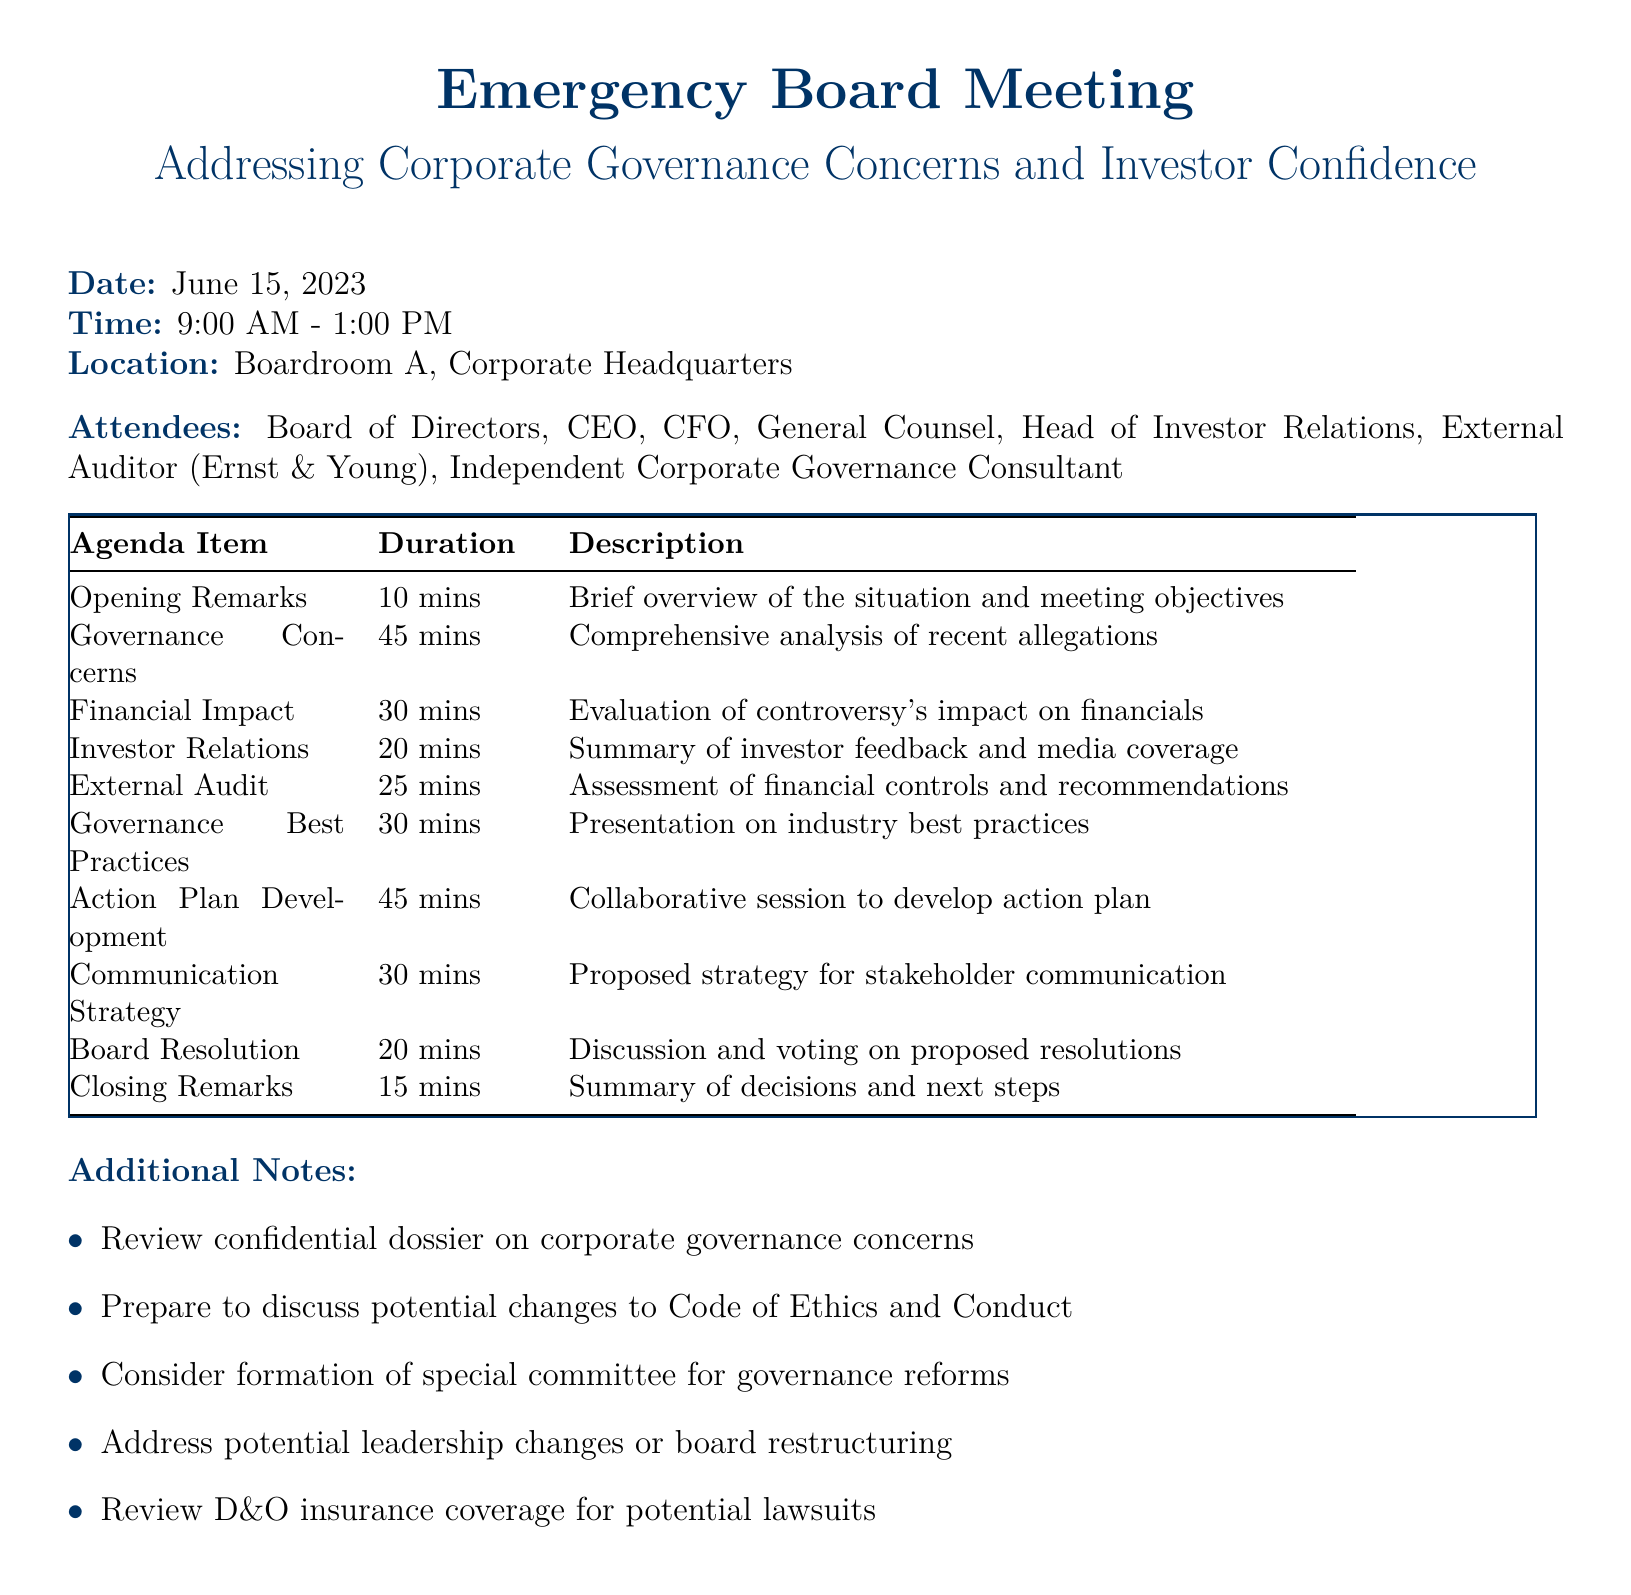What is the date of the meeting? The date of the meeting is mentioned in the document, which is specifically stated at the beginning.
Answer: June 15, 2023 Who is presenting the Financial Impact Assessment? The document lists presenters for each agenda item, thus indicating who is responsible for the Financial Impact Assessment.
Answer: CFO How long is the Opening Remarks segment? The duration of each agenda item is provided in the document next to the respective titles, indicating how long Opening Remarks will last.
Answer: 10 minutes What is being discussed in the Corporate Governance Best Practices segment? The description of the agenda item provides insight into the focus of the Corporate Governance Best Practices segment.
Answer: Industry best practices and recommendations for strengthening governance structure How many attendees are listed in the document? The document specifically enumerates the attendees, allowing us to count them directly from the provided list.
Answer: Seven What is one of the additional notes mentioned? Additional notes are listed at the end of the document, providing specific points that are relevant to the meeting's preparation.
Answer: Review confidential dossier on corporate governance concerns What is the location of the meeting? The document includes a clear statement regarding the location of the meeting, providing the precise venue.
Answer: Boardroom A, Corporate Headquarters What is the duration of the Investor Relations Update? The duration for each agenda item is provided, allowing for quick reference to the time allocated for the Investor Relations Update.
Answer: 20 minutes 